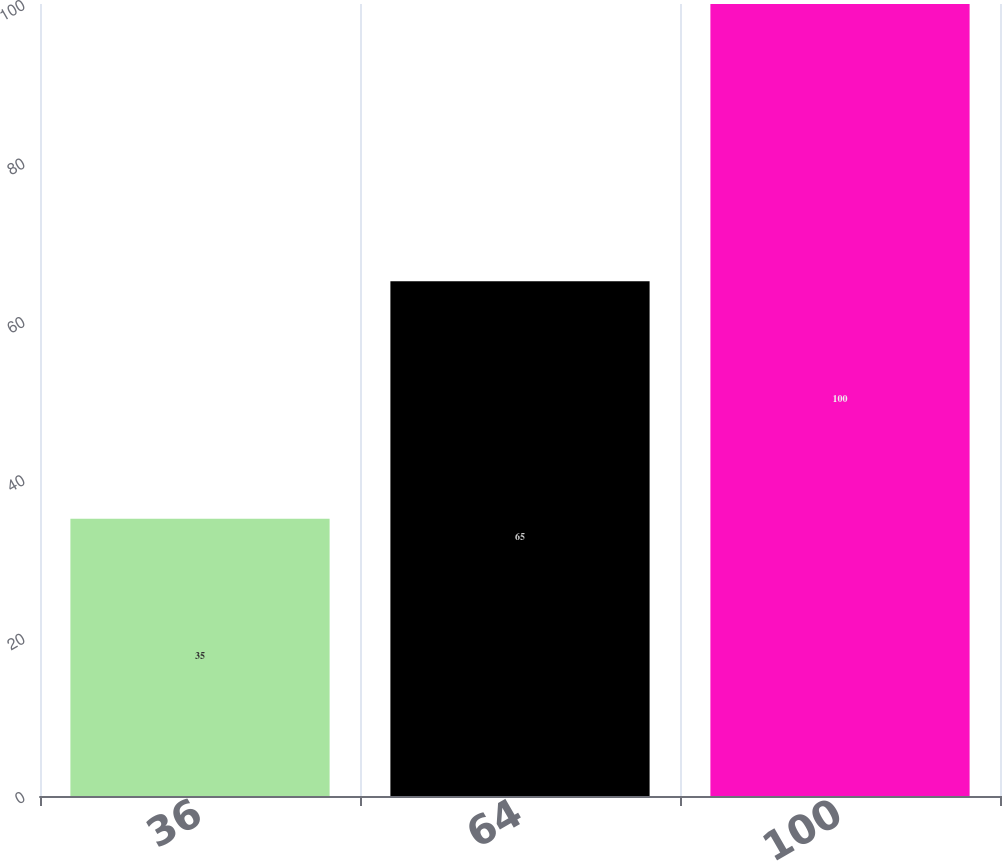<chart> <loc_0><loc_0><loc_500><loc_500><bar_chart><fcel>36<fcel>64<fcel>100<nl><fcel>35<fcel>65<fcel>100<nl></chart> 